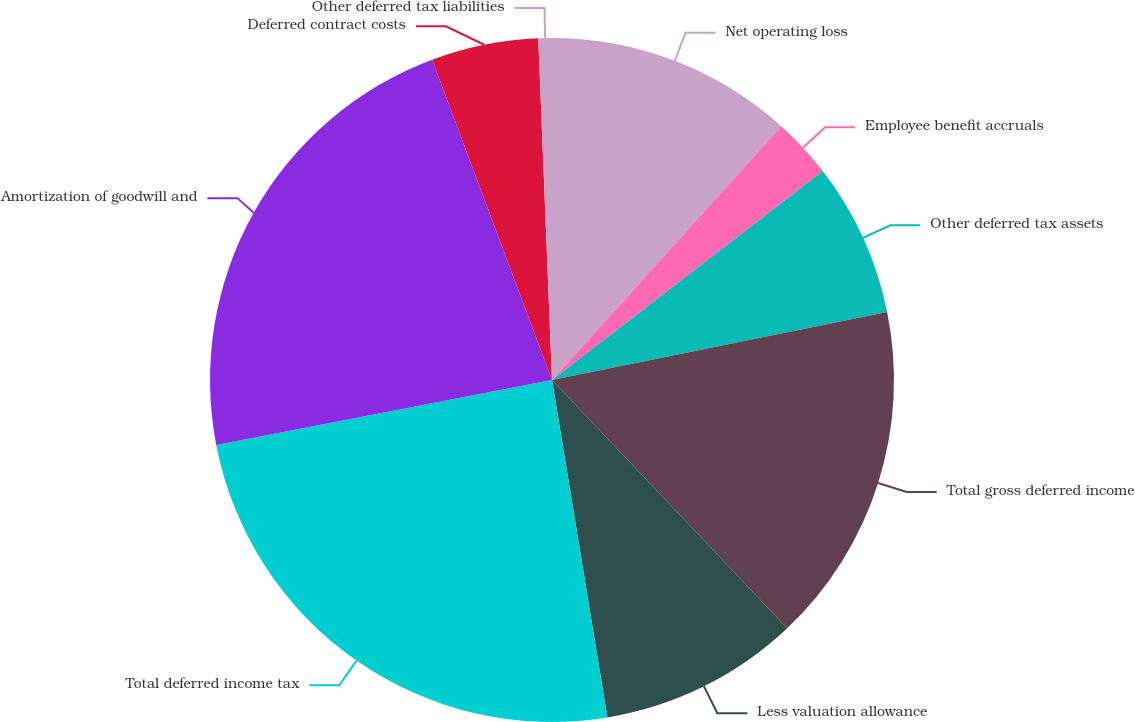<chart> <loc_0><loc_0><loc_500><loc_500><pie_chart><fcel>Net operating loss<fcel>Employee benefit accruals<fcel>Other deferred tax assets<fcel>Total gross deferred income<fcel>Less valuation allowance<fcel>Total deferred income tax<fcel>Amortization of goodwill and<fcel>Deferred contract costs<fcel>Other deferred tax liabilities<nl><fcel>11.69%<fcel>2.85%<fcel>7.27%<fcel>16.12%<fcel>9.48%<fcel>24.55%<fcel>22.34%<fcel>5.06%<fcel>0.64%<nl></chart> 